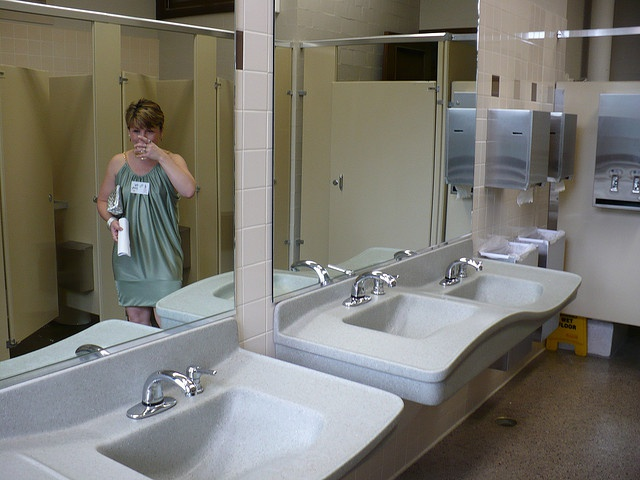Describe the objects in this image and their specific colors. I can see sink in gray, darkgray, and lightgray tones, sink in gray, darkgray, and lightgray tones, people in gray and black tones, sink in gray, darkgray, and lightgray tones, and sink in gray and darkgray tones in this image. 